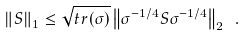<formula> <loc_0><loc_0><loc_500><loc_500>\left \| S \right \| _ { 1 } \leq \sqrt { t r ( \sigma ) } \left \| \sigma ^ { - 1 / 4 } S \sigma ^ { - 1 / 4 } \right \| _ { 2 } \ .</formula> 